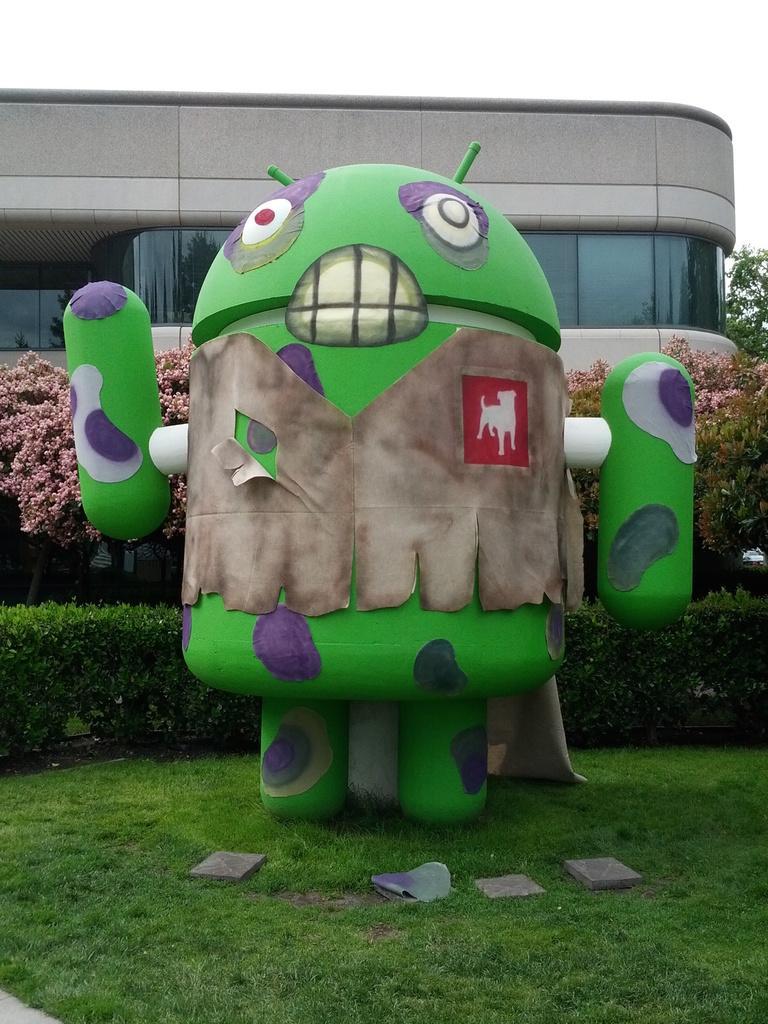In one or two sentences, can you explain what this image depicts? This picture is clicked outside. In the foreground we can see the green grass and some objects lying on the ground. In the center we can see a green color object which seems to be the carnival toy. In the background we can see the sky, plants, tree and an object which seems to be the building. 